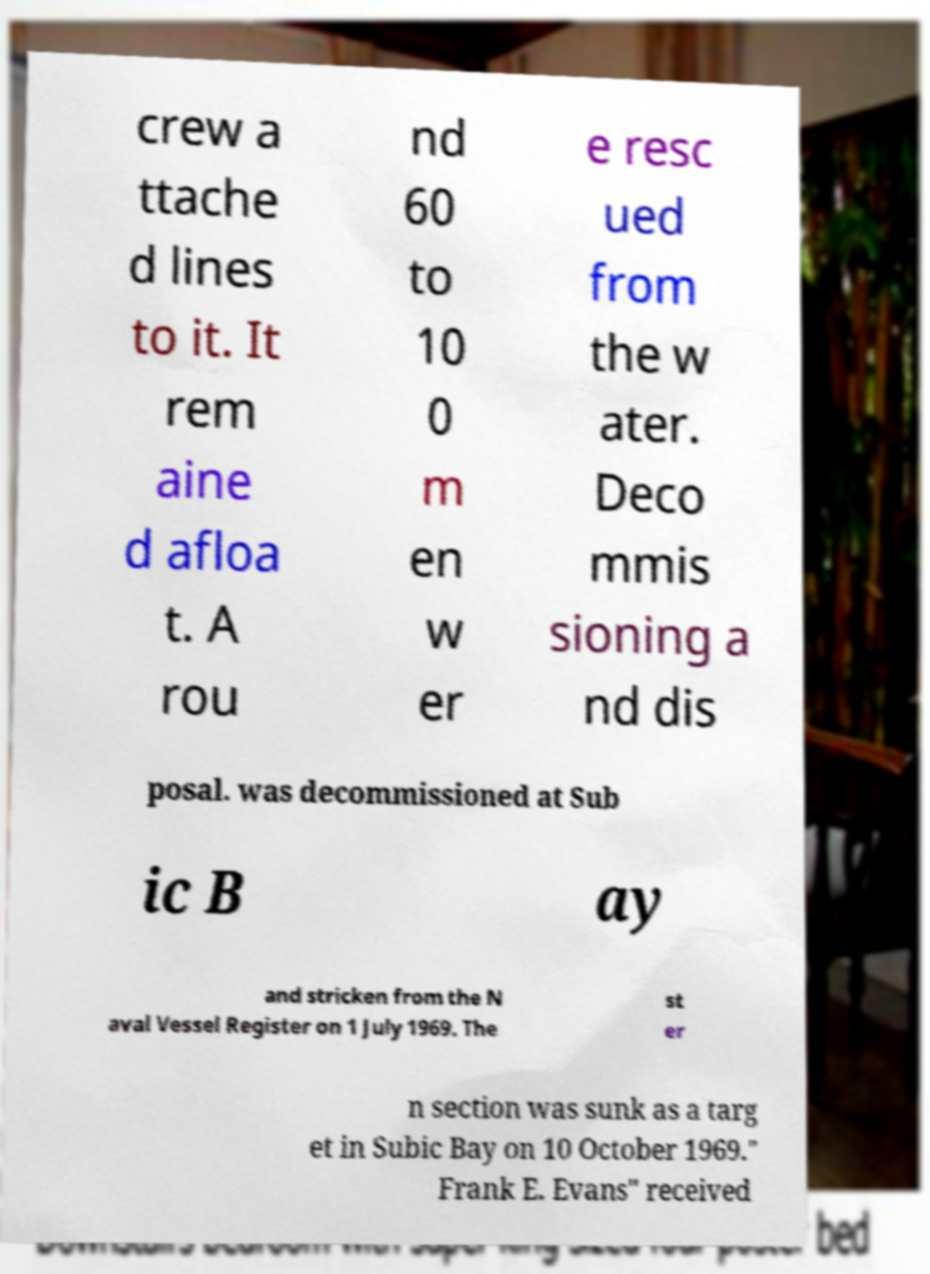There's text embedded in this image that I need extracted. Can you transcribe it verbatim? crew a ttache d lines to it. It rem aine d afloa t. A rou nd 60 to 10 0 m en w er e resc ued from the w ater. Deco mmis sioning a nd dis posal. was decommissioned at Sub ic B ay and stricken from the N aval Vessel Register on 1 July 1969. The st er n section was sunk as a targ et in Subic Bay on 10 October 1969." Frank E. Evans" received 